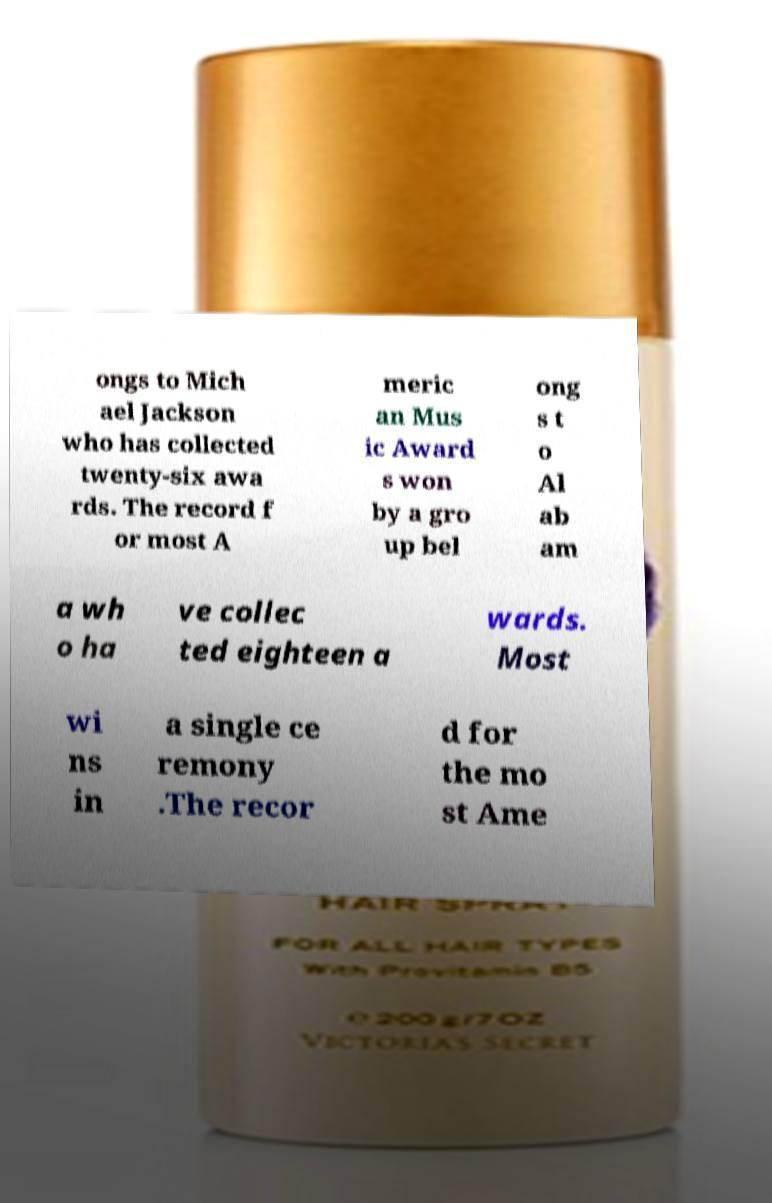There's text embedded in this image that I need extracted. Can you transcribe it verbatim? ongs to Mich ael Jackson who has collected twenty-six awa rds. The record f or most A meric an Mus ic Award s won by a gro up bel ong s t o Al ab am a wh o ha ve collec ted eighteen a wards. Most wi ns in a single ce remony .The recor d for the mo st Ame 